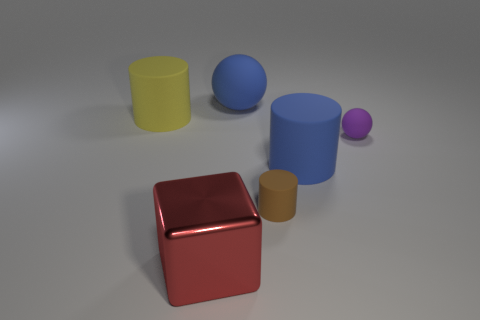Subtract all tiny brown cylinders. How many cylinders are left? 2 Add 1 large blue shiny spheres. How many objects exist? 7 Subtract all brown cylinders. How many cylinders are left? 2 Subtract 1 cylinders. How many cylinders are left? 2 Subtract all yellow metallic cubes. Subtract all tiny purple rubber spheres. How many objects are left? 5 Add 2 purple matte objects. How many purple matte objects are left? 3 Add 4 big cylinders. How many big cylinders exist? 6 Subtract 1 purple balls. How many objects are left? 5 Subtract all balls. How many objects are left? 4 Subtract all red cylinders. Subtract all blue spheres. How many cylinders are left? 3 